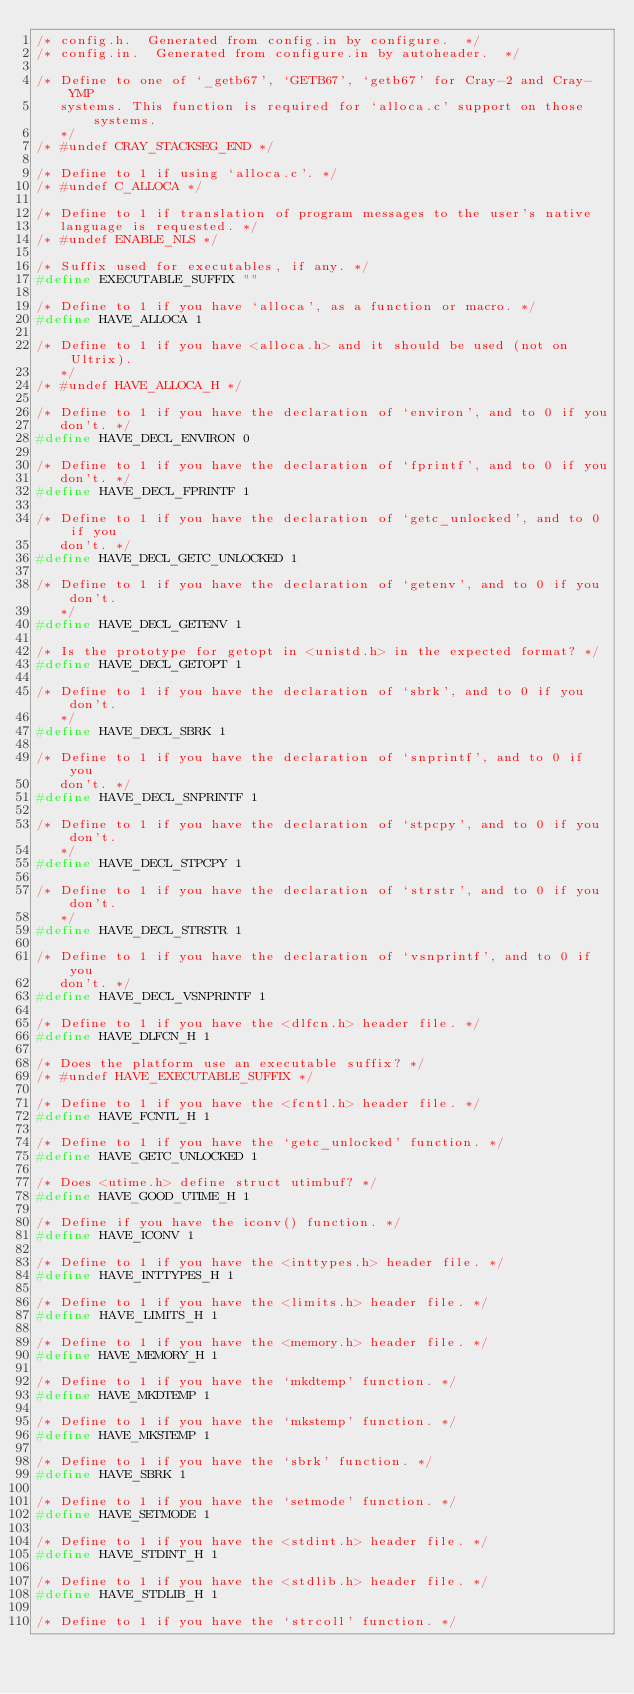<code> <loc_0><loc_0><loc_500><loc_500><_C_>/* config.h.  Generated from config.in by configure.  */
/* config.in.  Generated from configure.in by autoheader.  */

/* Define to one of `_getb67', `GETB67', `getb67' for Cray-2 and Cray-YMP
   systems. This function is required for `alloca.c' support on those systems.
   */
/* #undef CRAY_STACKSEG_END */

/* Define to 1 if using `alloca.c'. */
/* #undef C_ALLOCA */

/* Define to 1 if translation of program messages to the user's native
   language is requested. */
/* #undef ENABLE_NLS */

/* Suffix used for executables, if any. */
#define EXECUTABLE_SUFFIX ""

/* Define to 1 if you have `alloca', as a function or macro. */
#define HAVE_ALLOCA 1

/* Define to 1 if you have <alloca.h> and it should be used (not on Ultrix).
   */
/* #undef HAVE_ALLOCA_H */

/* Define to 1 if you have the declaration of `environ', and to 0 if you
   don't. */
#define HAVE_DECL_ENVIRON 0

/* Define to 1 if you have the declaration of `fprintf', and to 0 if you
   don't. */
#define HAVE_DECL_FPRINTF 1

/* Define to 1 if you have the declaration of `getc_unlocked', and to 0 if you
   don't. */
#define HAVE_DECL_GETC_UNLOCKED 1

/* Define to 1 if you have the declaration of `getenv', and to 0 if you don't.
   */
#define HAVE_DECL_GETENV 1

/* Is the prototype for getopt in <unistd.h> in the expected format? */
#define HAVE_DECL_GETOPT 1

/* Define to 1 if you have the declaration of `sbrk', and to 0 if you don't.
   */
#define HAVE_DECL_SBRK 1

/* Define to 1 if you have the declaration of `snprintf', and to 0 if you
   don't. */
#define HAVE_DECL_SNPRINTF 1

/* Define to 1 if you have the declaration of `stpcpy', and to 0 if you don't.
   */
#define HAVE_DECL_STPCPY 1

/* Define to 1 if you have the declaration of `strstr', and to 0 if you don't.
   */
#define HAVE_DECL_STRSTR 1

/* Define to 1 if you have the declaration of `vsnprintf', and to 0 if you
   don't. */
#define HAVE_DECL_VSNPRINTF 1

/* Define to 1 if you have the <dlfcn.h> header file. */
#define HAVE_DLFCN_H 1

/* Does the platform use an executable suffix? */
/* #undef HAVE_EXECUTABLE_SUFFIX */

/* Define to 1 if you have the <fcntl.h> header file. */
#define HAVE_FCNTL_H 1

/* Define to 1 if you have the `getc_unlocked' function. */
#define HAVE_GETC_UNLOCKED 1

/* Does <utime.h> define struct utimbuf? */
#define HAVE_GOOD_UTIME_H 1

/* Define if you have the iconv() function. */
#define HAVE_ICONV 1

/* Define to 1 if you have the <inttypes.h> header file. */
#define HAVE_INTTYPES_H 1

/* Define to 1 if you have the <limits.h> header file. */
#define HAVE_LIMITS_H 1

/* Define to 1 if you have the <memory.h> header file. */
#define HAVE_MEMORY_H 1

/* Define to 1 if you have the `mkdtemp' function. */
#define HAVE_MKDTEMP 1

/* Define to 1 if you have the `mkstemp' function. */
#define HAVE_MKSTEMP 1

/* Define to 1 if you have the `sbrk' function. */
#define HAVE_SBRK 1

/* Define to 1 if you have the `setmode' function. */
#define HAVE_SETMODE 1

/* Define to 1 if you have the <stdint.h> header file. */
#define HAVE_STDINT_H 1

/* Define to 1 if you have the <stdlib.h> header file. */
#define HAVE_STDLIB_H 1

/* Define to 1 if you have the `strcoll' function. */</code> 